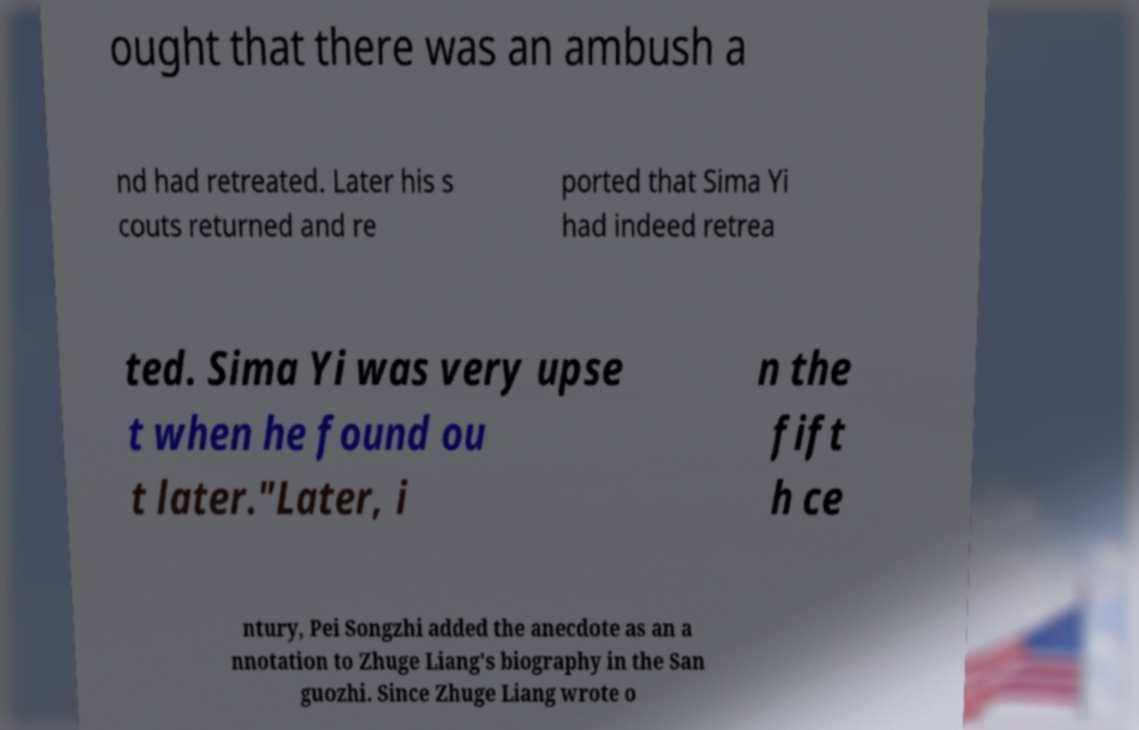I need the written content from this picture converted into text. Can you do that? ought that there was an ambush a nd had retreated. Later his s couts returned and re ported that Sima Yi had indeed retrea ted. Sima Yi was very upse t when he found ou t later."Later, i n the fift h ce ntury, Pei Songzhi added the anecdote as an a nnotation to Zhuge Liang's biography in the San guozhi. Since Zhuge Liang wrote o 